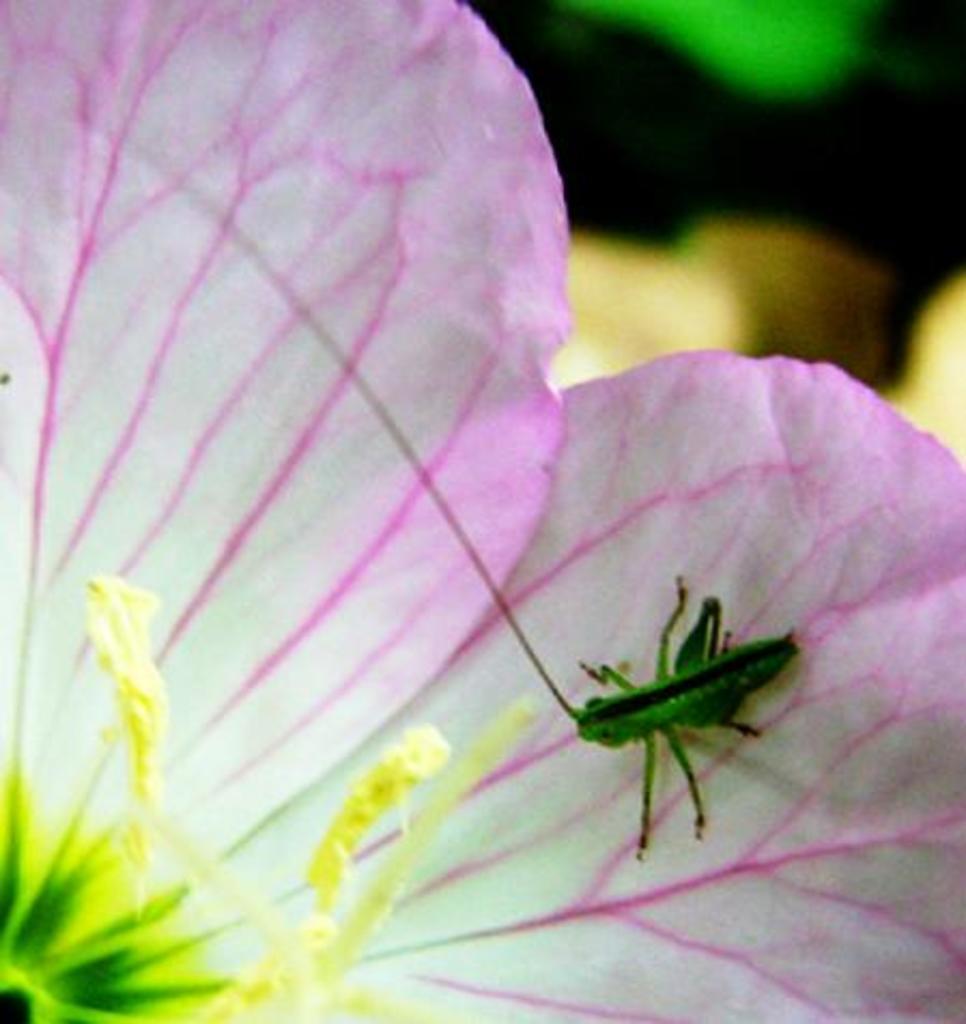In one or two sentences, can you explain what this image depicts? This image consists of a small insect in green color. It is on a flower petal. The flower petal is in pink and white color. At the bottom, we can see the pollen grains in yellow color. 